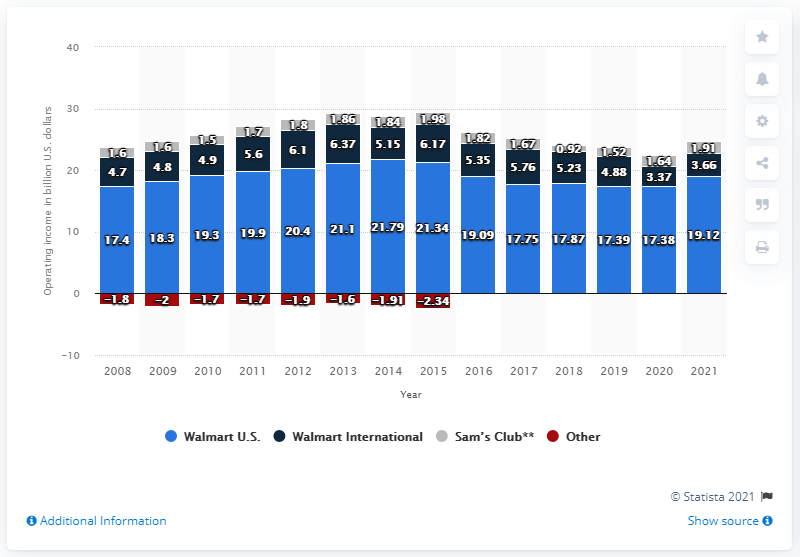Indicate a few pertinent items in this graphic. Walmart International's operating income in 2021 was 3.66 billion dollars. 